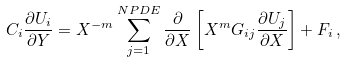Convert formula to latex. <formula><loc_0><loc_0><loc_500><loc_500>C _ { i } \frac { \partial U _ { i } } { \partial Y } = X ^ { - m } \sum _ { j = 1 } ^ { N P D E } \frac { \partial } { \partial X } \left [ X ^ { m } G _ { i j } \frac { \partial U _ { j } } { \partial X } \right ] + F _ { i } \, ,</formula> 